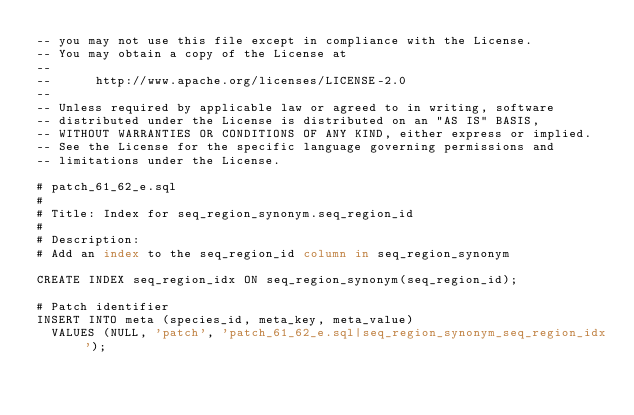<code> <loc_0><loc_0><loc_500><loc_500><_SQL_>-- you may not use this file except in compliance with the License.
-- You may obtain a copy of the License at
-- 
--      http://www.apache.org/licenses/LICENSE-2.0
-- 
-- Unless required by applicable law or agreed to in writing, software
-- distributed under the License is distributed on an "AS IS" BASIS,
-- WITHOUT WARRANTIES OR CONDITIONS OF ANY KIND, either express or implied.
-- See the License for the specific language governing permissions and
-- limitations under the License.

# patch_61_62_e.sql
#
# Title: Index for seq_region_synonym.seq_region_id
#
# Description:
# Add an index to the seq_region_id column in seq_region_synonym

CREATE INDEX seq_region_idx ON seq_region_synonym(seq_region_id);

# Patch identifier
INSERT INTO meta (species_id, meta_key, meta_value)
  VALUES (NULL, 'patch', 'patch_61_62_e.sql|seq_region_synonym_seq_region_idx');
</code> 